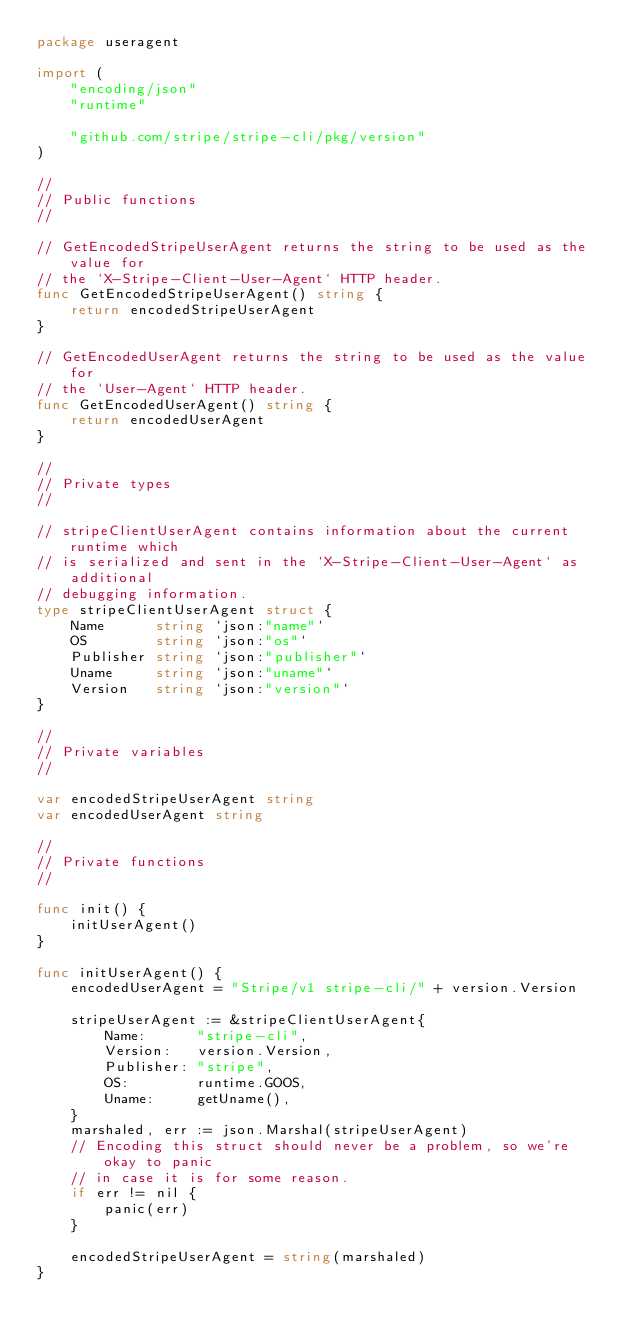<code> <loc_0><loc_0><loc_500><loc_500><_Go_>package useragent

import (
	"encoding/json"
	"runtime"

	"github.com/stripe/stripe-cli/pkg/version"
)

//
// Public functions
//

// GetEncodedStripeUserAgent returns the string to be used as the value for
// the `X-Stripe-Client-User-Agent` HTTP header.
func GetEncodedStripeUserAgent() string {
	return encodedStripeUserAgent
}

// GetEncodedUserAgent returns the string to be used as the value for
// the `User-Agent` HTTP header.
func GetEncodedUserAgent() string {
	return encodedUserAgent
}

//
// Private types
//

// stripeClientUserAgent contains information about the current runtime which
// is serialized and sent in the `X-Stripe-Client-User-Agent` as additional
// debugging information.
type stripeClientUserAgent struct {
	Name      string `json:"name"`
	OS        string `json:"os"`
	Publisher string `json:"publisher"`
	Uname     string `json:"uname"`
	Version   string `json:"version"`
}

//
// Private variables
//

var encodedStripeUserAgent string
var encodedUserAgent string

//
// Private functions
//

func init() {
	initUserAgent()
}

func initUserAgent() {
	encodedUserAgent = "Stripe/v1 stripe-cli/" + version.Version

	stripeUserAgent := &stripeClientUserAgent{
		Name:      "stripe-cli",
		Version:   version.Version,
		Publisher: "stripe",
		OS:        runtime.GOOS,
		Uname:     getUname(),
	}
	marshaled, err := json.Marshal(stripeUserAgent)
	// Encoding this struct should never be a problem, so we're okay to panic
	// in case it is for some reason.
	if err != nil {
		panic(err)
	}

	encodedStripeUserAgent = string(marshaled)
}
</code> 